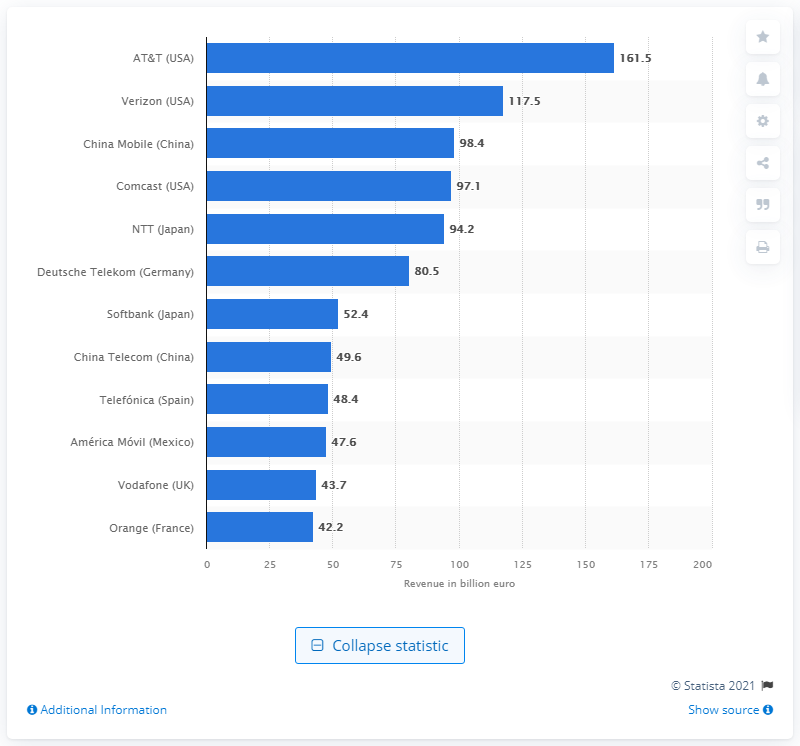Point out several critical features in this image. AT&T's sales in 2020 were $161.5 billion. In 2020, Verizon's sales were 117.5. 